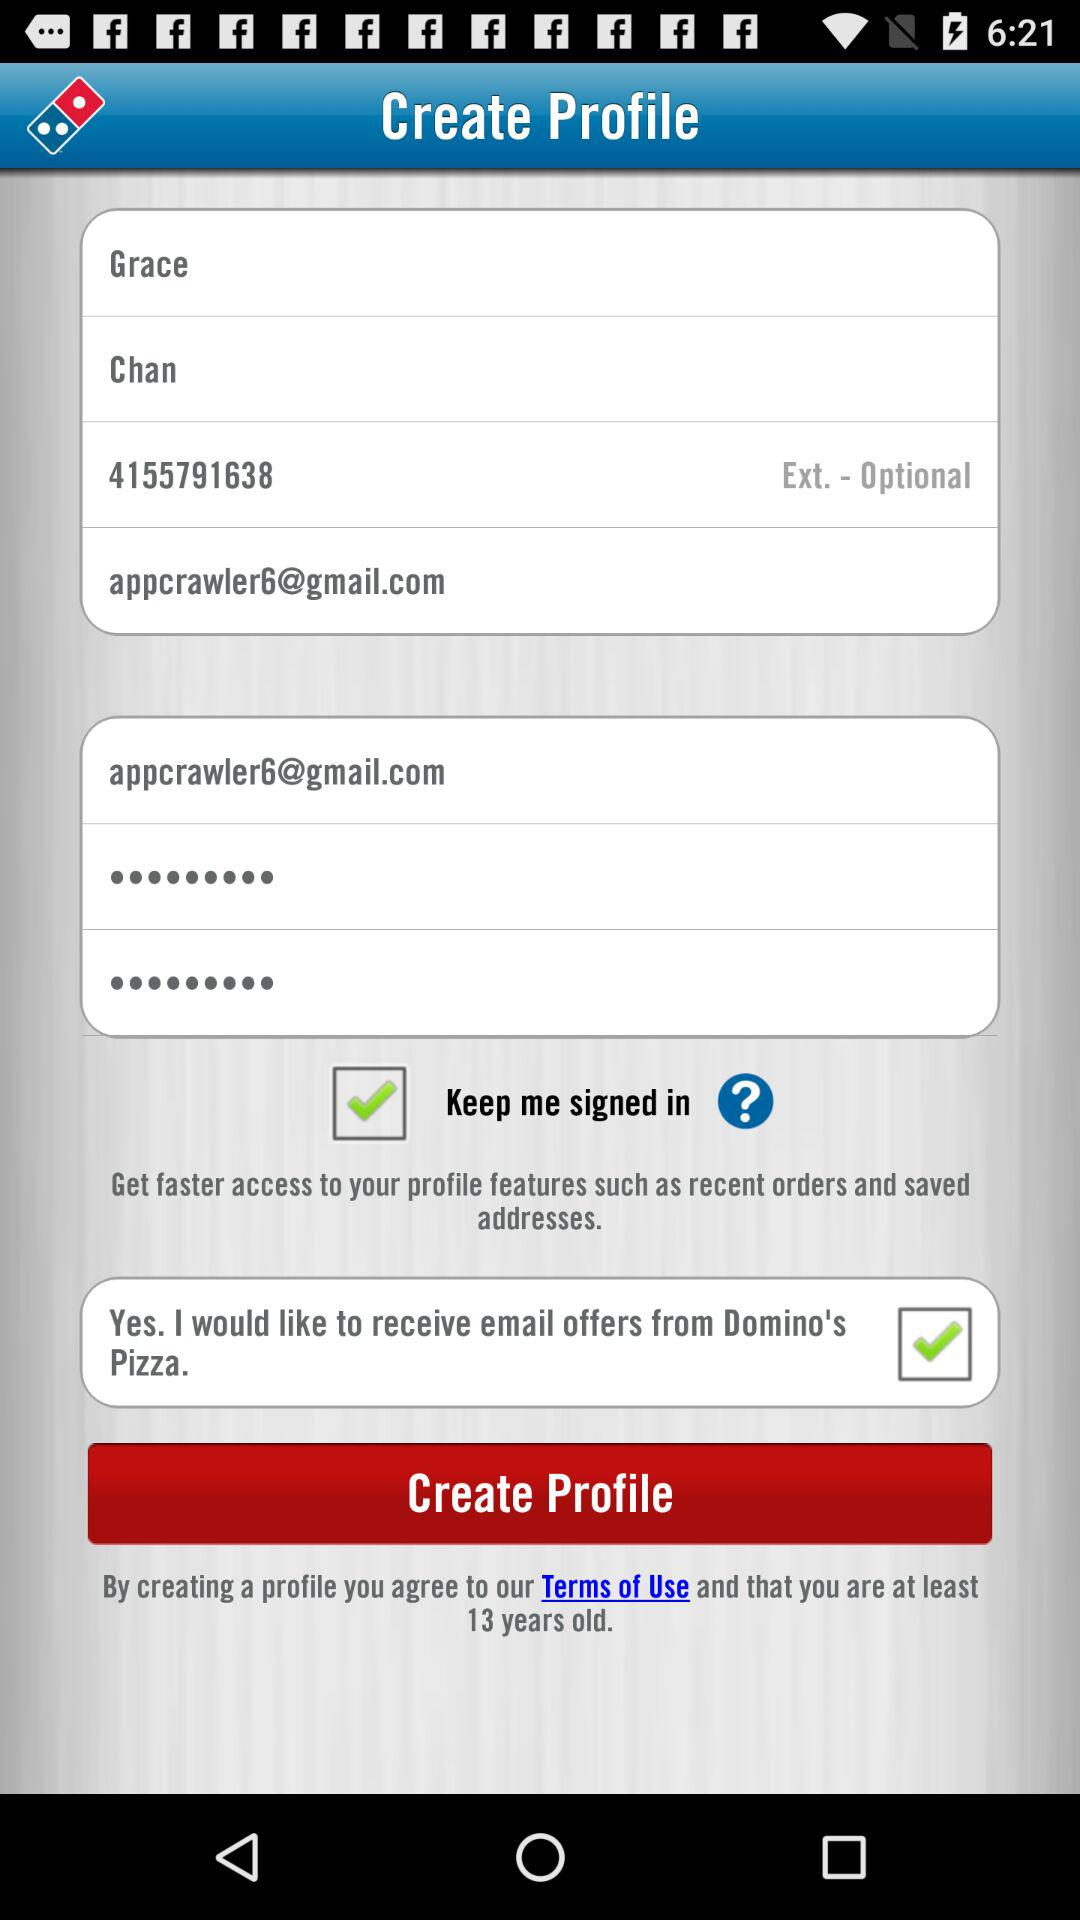How many text inputs have the value 'appcrawler6@gmail.com'?
Answer the question using a single word or phrase. 2 